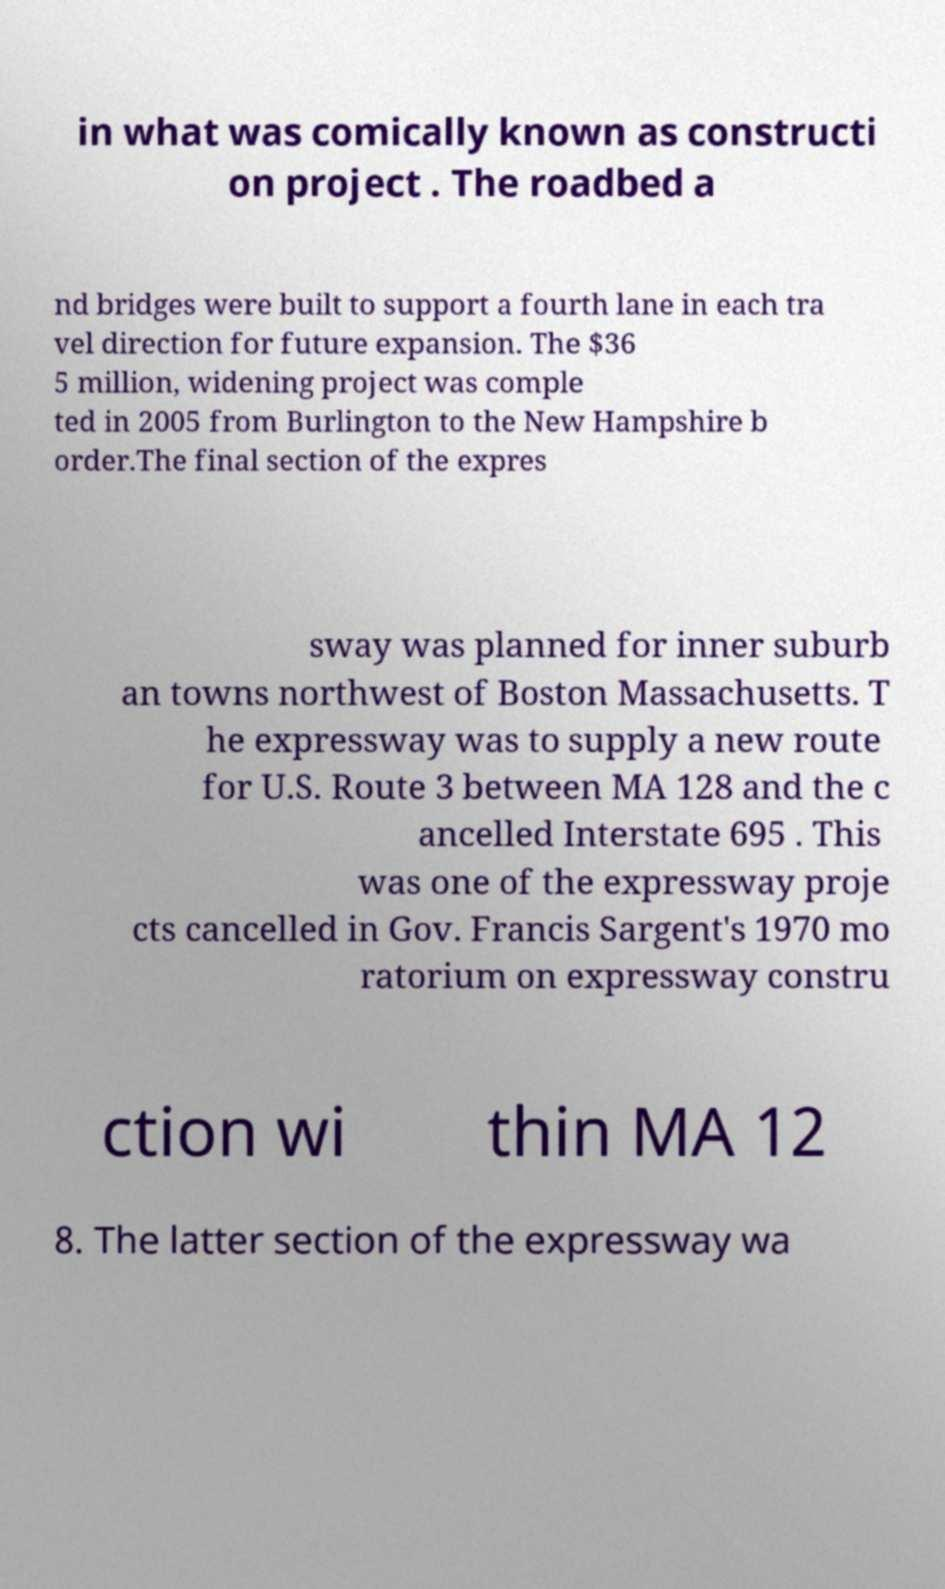Please identify and transcribe the text found in this image. in what was comically known as constructi on project . The roadbed a nd bridges were built to support a fourth lane in each tra vel direction for future expansion. The $36 5 million, widening project was comple ted in 2005 from Burlington to the New Hampshire b order.The final section of the expres sway was planned for inner suburb an towns northwest of Boston Massachusetts. T he expressway was to supply a new route for U.S. Route 3 between MA 128 and the c ancelled Interstate 695 . This was one of the expressway proje cts cancelled in Gov. Francis Sargent's 1970 mo ratorium on expressway constru ction wi thin MA 12 8. The latter section of the expressway wa 